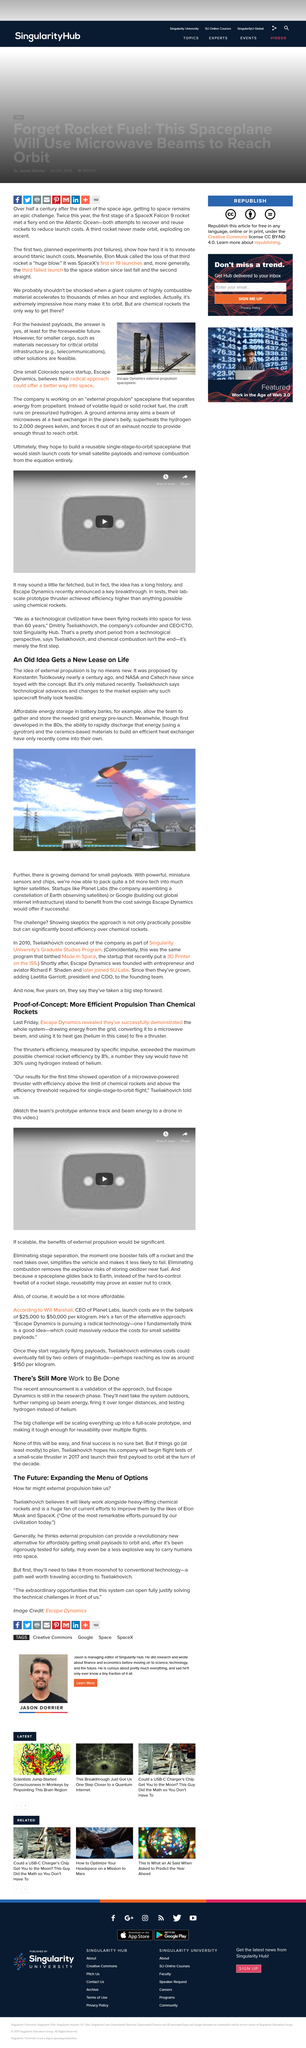Indicate a few pertinent items in this graphic. Escape Dynamics are headquartered in Colorado. The thruster's efficiency, measured by specific impulse, exceeded the maximum possible chemical rocket efficiency by 8%, indicating a significant improvement over traditional chemical rockets. External propulsion will work alongside heavy-lifting chemical rockets, as stated by Tseliakhovich. The biggest challenge will be scaling everything up into a full-scale prototype. In his proposal, Tseliakhovich states that technological advancements and market changes have made interstellar travel feasible. 